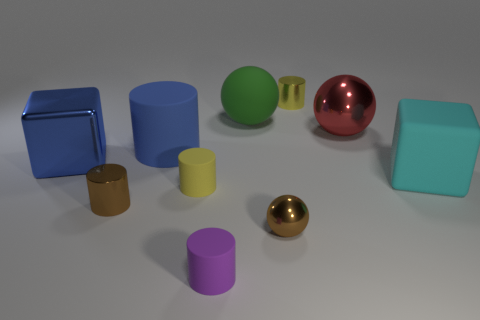What is the material of the brown thing that is right of the large blue rubber cylinder?
Make the answer very short. Metal. Is there anything else that has the same color as the large shiny ball?
Keep it short and to the point. No. There is a yellow object that is the same material as the cyan cube; what is its size?
Provide a succinct answer. Small. How many small things are either brown blocks or blue blocks?
Provide a short and direct response. 0. How big is the metallic ball behind the large matte object that is in front of the cube to the left of the small brown cylinder?
Offer a terse response. Large. How many gray spheres have the same size as the cyan matte cube?
Ensure brevity in your answer.  0. What number of objects are either large red objects or tiny metal things on the right side of the tiny brown cylinder?
Your answer should be compact. 3. The tiny yellow metal object is what shape?
Your answer should be very brief. Cylinder. Is the color of the big shiny block the same as the large cylinder?
Your answer should be very brief. Yes. There is a matte ball that is the same size as the red metallic object; what is its color?
Give a very brief answer. Green. 